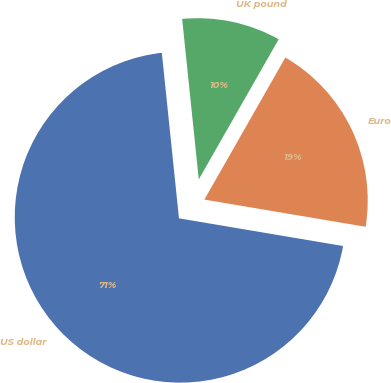Convert chart. <chart><loc_0><loc_0><loc_500><loc_500><pie_chart><fcel>US dollar<fcel>Euro<fcel>UK pound<nl><fcel>70.69%<fcel>19.41%<fcel>9.89%<nl></chart> 